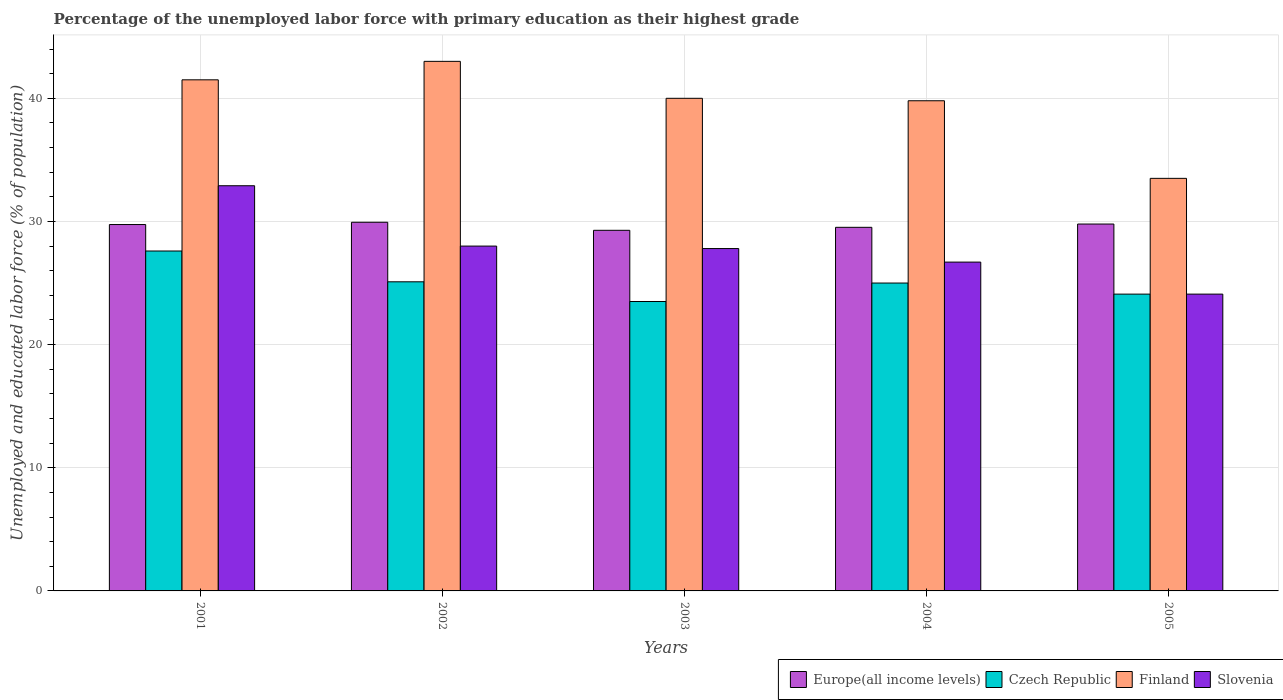How many bars are there on the 1st tick from the left?
Provide a succinct answer. 4. How many bars are there on the 5th tick from the right?
Give a very brief answer. 4. What is the label of the 4th group of bars from the left?
Give a very brief answer. 2004. In how many cases, is the number of bars for a given year not equal to the number of legend labels?
Provide a short and direct response. 0. What is the percentage of the unemployed labor force with primary education in Europe(all income levels) in 2001?
Your response must be concise. 29.75. Across all years, what is the maximum percentage of the unemployed labor force with primary education in Czech Republic?
Ensure brevity in your answer.  27.6. Across all years, what is the minimum percentage of the unemployed labor force with primary education in Europe(all income levels)?
Provide a short and direct response. 29.28. In which year was the percentage of the unemployed labor force with primary education in Czech Republic maximum?
Your answer should be compact. 2001. What is the total percentage of the unemployed labor force with primary education in Finland in the graph?
Make the answer very short. 197.8. What is the difference between the percentage of the unemployed labor force with primary education in Czech Republic in 2003 and that in 2005?
Keep it short and to the point. -0.6. What is the difference between the percentage of the unemployed labor force with primary education in Czech Republic in 2002 and the percentage of the unemployed labor force with primary education in Slovenia in 2004?
Offer a very short reply. -1.6. What is the average percentage of the unemployed labor force with primary education in Czech Republic per year?
Make the answer very short. 25.06. In the year 2002, what is the difference between the percentage of the unemployed labor force with primary education in Europe(all income levels) and percentage of the unemployed labor force with primary education in Finland?
Your answer should be very brief. -13.07. In how many years, is the percentage of the unemployed labor force with primary education in Finland greater than 36 %?
Your response must be concise. 4. What is the ratio of the percentage of the unemployed labor force with primary education in Slovenia in 2001 to that in 2002?
Provide a short and direct response. 1.18. What is the difference between the highest and the lowest percentage of the unemployed labor force with primary education in Europe(all income levels)?
Give a very brief answer. 0.65. In how many years, is the percentage of the unemployed labor force with primary education in Europe(all income levels) greater than the average percentage of the unemployed labor force with primary education in Europe(all income levels) taken over all years?
Offer a terse response. 3. Is the sum of the percentage of the unemployed labor force with primary education in Slovenia in 2001 and 2004 greater than the maximum percentage of the unemployed labor force with primary education in Europe(all income levels) across all years?
Ensure brevity in your answer.  Yes. What does the 4th bar from the right in 2002 represents?
Provide a succinct answer. Europe(all income levels). Are all the bars in the graph horizontal?
Give a very brief answer. No. How many years are there in the graph?
Give a very brief answer. 5. What is the difference between two consecutive major ticks on the Y-axis?
Give a very brief answer. 10. Are the values on the major ticks of Y-axis written in scientific E-notation?
Your answer should be very brief. No. Does the graph contain any zero values?
Your response must be concise. No. Where does the legend appear in the graph?
Your answer should be compact. Bottom right. How many legend labels are there?
Ensure brevity in your answer.  4. How are the legend labels stacked?
Make the answer very short. Horizontal. What is the title of the graph?
Offer a very short reply. Percentage of the unemployed labor force with primary education as their highest grade. What is the label or title of the Y-axis?
Your answer should be compact. Unemployed and educated labor force (% of population). What is the Unemployed and educated labor force (% of population) in Europe(all income levels) in 2001?
Offer a terse response. 29.75. What is the Unemployed and educated labor force (% of population) in Czech Republic in 2001?
Ensure brevity in your answer.  27.6. What is the Unemployed and educated labor force (% of population) in Finland in 2001?
Offer a very short reply. 41.5. What is the Unemployed and educated labor force (% of population) of Slovenia in 2001?
Your answer should be compact. 32.9. What is the Unemployed and educated labor force (% of population) of Europe(all income levels) in 2002?
Offer a very short reply. 29.93. What is the Unemployed and educated labor force (% of population) in Czech Republic in 2002?
Give a very brief answer. 25.1. What is the Unemployed and educated labor force (% of population) of Finland in 2002?
Provide a succinct answer. 43. What is the Unemployed and educated labor force (% of population) in Europe(all income levels) in 2003?
Your answer should be compact. 29.28. What is the Unemployed and educated labor force (% of population) of Slovenia in 2003?
Offer a very short reply. 27.8. What is the Unemployed and educated labor force (% of population) of Europe(all income levels) in 2004?
Your response must be concise. 29.52. What is the Unemployed and educated labor force (% of population) of Czech Republic in 2004?
Your answer should be compact. 25. What is the Unemployed and educated labor force (% of population) in Finland in 2004?
Provide a short and direct response. 39.8. What is the Unemployed and educated labor force (% of population) in Slovenia in 2004?
Keep it short and to the point. 26.7. What is the Unemployed and educated labor force (% of population) in Europe(all income levels) in 2005?
Provide a succinct answer. 29.79. What is the Unemployed and educated labor force (% of population) of Czech Republic in 2005?
Provide a short and direct response. 24.1. What is the Unemployed and educated labor force (% of population) in Finland in 2005?
Your response must be concise. 33.5. What is the Unemployed and educated labor force (% of population) of Slovenia in 2005?
Your answer should be very brief. 24.1. Across all years, what is the maximum Unemployed and educated labor force (% of population) of Europe(all income levels)?
Provide a short and direct response. 29.93. Across all years, what is the maximum Unemployed and educated labor force (% of population) of Czech Republic?
Provide a short and direct response. 27.6. Across all years, what is the maximum Unemployed and educated labor force (% of population) of Finland?
Ensure brevity in your answer.  43. Across all years, what is the maximum Unemployed and educated labor force (% of population) of Slovenia?
Give a very brief answer. 32.9. Across all years, what is the minimum Unemployed and educated labor force (% of population) of Europe(all income levels)?
Your response must be concise. 29.28. Across all years, what is the minimum Unemployed and educated labor force (% of population) of Czech Republic?
Provide a succinct answer. 23.5. Across all years, what is the minimum Unemployed and educated labor force (% of population) in Finland?
Offer a very short reply. 33.5. Across all years, what is the minimum Unemployed and educated labor force (% of population) of Slovenia?
Your response must be concise. 24.1. What is the total Unemployed and educated labor force (% of population) in Europe(all income levels) in the graph?
Your response must be concise. 148.28. What is the total Unemployed and educated labor force (% of population) of Czech Republic in the graph?
Provide a succinct answer. 125.3. What is the total Unemployed and educated labor force (% of population) in Finland in the graph?
Your response must be concise. 197.8. What is the total Unemployed and educated labor force (% of population) in Slovenia in the graph?
Provide a succinct answer. 139.5. What is the difference between the Unemployed and educated labor force (% of population) in Europe(all income levels) in 2001 and that in 2002?
Give a very brief answer. -0.18. What is the difference between the Unemployed and educated labor force (% of population) of Czech Republic in 2001 and that in 2002?
Your answer should be very brief. 2.5. What is the difference between the Unemployed and educated labor force (% of population) of Slovenia in 2001 and that in 2002?
Make the answer very short. 4.9. What is the difference between the Unemployed and educated labor force (% of population) in Europe(all income levels) in 2001 and that in 2003?
Give a very brief answer. 0.47. What is the difference between the Unemployed and educated labor force (% of population) in Finland in 2001 and that in 2003?
Ensure brevity in your answer.  1.5. What is the difference between the Unemployed and educated labor force (% of population) of Slovenia in 2001 and that in 2003?
Your response must be concise. 5.1. What is the difference between the Unemployed and educated labor force (% of population) of Europe(all income levels) in 2001 and that in 2004?
Your answer should be compact. 0.23. What is the difference between the Unemployed and educated labor force (% of population) in Czech Republic in 2001 and that in 2004?
Ensure brevity in your answer.  2.6. What is the difference between the Unemployed and educated labor force (% of population) of Finland in 2001 and that in 2004?
Offer a terse response. 1.7. What is the difference between the Unemployed and educated labor force (% of population) of Slovenia in 2001 and that in 2004?
Offer a very short reply. 6.2. What is the difference between the Unemployed and educated labor force (% of population) in Europe(all income levels) in 2001 and that in 2005?
Offer a terse response. -0.04. What is the difference between the Unemployed and educated labor force (% of population) of Europe(all income levels) in 2002 and that in 2003?
Provide a succinct answer. 0.65. What is the difference between the Unemployed and educated labor force (% of population) of Finland in 2002 and that in 2003?
Give a very brief answer. 3. What is the difference between the Unemployed and educated labor force (% of population) of Slovenia in 2002 and that in 2003?
Give a very brief answer. 0.2. What is the difference between the Unemployed and educated labor force (% of population) in Europe(all income levels) in 2002 and that in 2004?
Make the answer very short. 0.41. What is the difference between the Unemployed and educated labor force (% of population) of Europe(all income levels) in 2002 and that in 2005?
Your answer should be compact. 0.14. What is the difference between the Unemployed and educated labor force (% of population) in Slovenia in 2002 and that in 2005?
Your answer should be compact. 3.9. What is the difference between the Unemployed and educated labor force (% of population) of Europe(all income levels) in 2003 and that in 2004?
Ensure brevity in your answer.  -0.24. What is the difference between the Unemployed and educated labor force (% of population) in Finland in 2003 and that in 2004?
Offer a very short reply. 0.2. What is the difference between the Unemployed and educated labor force (% of population) in Slovenia in 2003 and that in 2004?
Keep it short and to the point. 1.1. What is the difference between the Unemployed and educated labor force (% of population) in Europe(all income levels) in 2003 and that in 2005?
Give a very brief answer. -0.51. What is the difference between the Unemployed and educated labor force (% of population) of Czech Republic in 2003 and that in 2005?
Ensure brevity in your answer.  -0.6. What is the difference between the Unemployed and educated labor force (% of population) of Finland in 2003 and that in 2005?
Make the answer very short. 6.5. What is the difference between the Unemployed and educated labor force (% of population) in Europe(all income levels) in 2004 and that in 2005?
Your answer should be very brief. -0.27. What is the difference between the Unemployed and educated labor force (% of population) of Finland in 2004 and that in 2005?
Give a very brief answer. 6.3. What is the difference between the Unemployed and educated labor force (% of population) of Europe(all income levels) in 2001 and the Unemployed and educated labor force (% of population) of Czech Republic in 2002?
Keep it short and to the point. 4.65. What is the difference between the Unemployed and educated labor force (% of population) of Europe(all income levels) in 2001 and the Unemployed and educated labor force (% of population) of Finland in 2002?
Provide a succinct answer. -13.25. What is the difference between the Unemployed and educated labor force (% of population) of Europe(all income levels) in 2001 and the Unemployed and educated labor force (% of population) of Slovenia in 2002?
Make the answer very short. 1.75. What is the difference between the Unemployed and educated labor force (% of population) of Czech Republic in 2001 and the Unemployed and educated labor force (% of population) of Finland in 2002?
Keep it short and to the point. -15.4. What is the difference between the Unemployed and educated labor force (% of population) in Czech Republic in 2001 and the Unemployed and educated labor force (% of population) in Slovenia in 2002?
Your response must be concise. -0.4. What is the difference between the Unemployed and educated labor force (% of population) of Europe(all income levels) in 2001 and the Unemployed and educated labor force (% of population) of Czech Republic in 2003?
Ensure brevity in your answer.  6.25. What is the difference between the Unemployed and educated labor force (% of population) in Europe(all income levels) in 2001 and the Unemployed and educated labor force (% of population) in Finland in 2003?
Provide a succinct answer. -10.25. What is the difference between the Unemployed and educated labor force (% of population) in Europe(all income levels) in 2001 and the Unemployed and educated labor force (% of population) in Slovenia in 2003?
Ensure brevity in your answer.  1.95. What is the difference between the Unemployed and educated labor force (% of population) in Czech Republic in 2001 and the Unemployed and educated labor force (% of population) in Finland in 2003?
Offer a terse response. -12.4. What is the difference between the Unemployed and educated labor force (% of population) in Finland in 2001 and the Unemployed and educated labor force (% of population) in Slovenia in 2003?
Keep it short and to the point. 13.7. What is the difference between the Unemployed and educated labor force (% of population) in Europe(all income levels) in 2001 and the Unemployed and educated labor force (% of population) in Czech Republic in 2004?
Your answer should be compact. 4.75. What is the difference between the Unemployed and educated labor force (% of population) in Europe(all income levels) in 2001 and the Unemployed and educated labor force (% of population) in Finland in 2004?
Make the answer very short. -10.05. What is the difference between the Unemployed and educated labor force (% of population) of Europe(all income levels) in 2001 and the Unemployed and educated labor force (% of population) of Slovenia in 2004?
Offer a terse response. 3.05. What is the difference between the Unemployed and educated labor force (% of population) in Czech Republic in 2001 and the Unemployed and educated labor force (% of population) in Finland in 2004?
Your answer should be compact. -12.2. What is the difference between the Unemployed and educated labor force (% of population) of Czech Republic in 2001 and the Unemployed and educated labor force (% of population) of Slovenia in 2004?
Offer a terse response. 0.9. What is the difference between the Unemployed and educated labor force (% of population) in Finland in 2001 and the Unemployed and educated labor force (% of population) in Slovenia in 2004?
Your response must be concise. 14.8. What is the difference between the Unemployed and educated labor force (% of population) of Europe(all income levels) in 2001 and the Unemployed and educated labor force (% of population) of Czech Republic in 2005?
Your answer should be compact. 5.65. What is the difference between the Unemployed and educated labor force (% of population) in Europe(all income levels) in 2001 and the Unemployed and educated labor force (% of population) in Finland in 2005?
Provide a short and direct response. -3.75. What is the difference between the Unemployed and educated labor force (% of population) in Europe(all income levels) in 2001 and the Unemployed and educated labor force (% of population) in Slovenia in 2005?
Your answer should be compact. 5.65. What is the difference between the Unemployed and educated labor force (% of population) of Czech Republic in 2001 and the Unemployed and educated labor force (% of population) of Finland in 2005?
Ensure brevity in your answer.  -5.9. What is the difference between the Unemployed and educated labor force (% of population) of Czech Republic in 2001 and the Unemployed and educated labor force (% of population) of Slovenia in 2005?
Offer a very short reply. 3.5. What is the difference between the Unemployed and educated labor force (% of population) of Finland in 2001 and the Unemployed and educated labor force (% of population) of Slovenia in 2005?
Your answer should be compact. 17.4. What is the difference between the Unemployed and educated labor force (% of population) of Europe(all income levels) in 2002 and the Unemployed and educated labor force (% of population) of Czech Republic in 2003?
Your answer should be compact. 6.43. What is the difference between the Unemployed and educated labor force (% of population) of Europe(all income levels) in 2002 and the Unemployed and educated labor force (% of population) of Finland in 2003?
Your response must be concise. -10.07. What is the difference between the Unemployed and educated labor force (% of population) of Europe(all income levels) in 2002 and the Unemployed and educated labor force (% of population) of Slovenia in 2003?
Your answer should be very brief. 2.13. What is the difference between the Unemployed and educated labor force (% of population) of Czech Republic in 2002 and the Unemployed and educated labor force (% of population) of Finland in 2003?
Your answer should be compact. -14.9. What is the difference between the Unemployed and educated labor force (% of population) in Finland in 2002 and the Unemployed and educated labor force (% of population) in Slovenia in 2003?
Your answer should be compact. 15.2. What is the difference between the Unemployed and educated labor force (% of population) of Europe(all income levels) in 2002 and the Unemployed and educated labor force (% of population) of Czech Republic in 2004?
Provide a short and direct response. 4.93. What is the difference between the Unemployed and educated labor force (% of population) in Europe(all income levels) in 2002 and the Unemployed and educated labor force (% of population) in Finland in 2004?
Make the answer very short. -9.87. What is the difference between the Unemployed and educated labor force (% of population) in Europe(all income levels) in 2002 and the Unemployed and educated labor force (% of population) in Slovenia in 2004?
Ensure brevity in your answer.  3.23. What is the difference between the Unemployed and educated labor force (% of population) of Czech Republic in 2002 and the Unemployed and educated labor force (% of population) of Finland in 2004?
Provide a short and direct response. -14.7. What is the difference between the Unemployed and educated labor force (% of population) of Czech Republic in 2002 and the Unemployed and educated labor force (% of population) of Slovenia in 2004?
Give a very brief answer. -1.6. What is the difference between the Unemployed and educated labor force (% of population) of Europe(all income levels) in 2002 and the Unemployed and educated labor force (% of population) of Czech Republic in 2005?
Your response must be concise. 5.83. What is the difference between the Unemployed and educated labor force (% of population) of Europe(all income levels) in 2002 and the Unemployed and educated labor force (% of population) of Finland in 2005?
Ensure brevity in your answer.  -3.57. What is the difference between the Unemployed and educated labor force (% of population) of Europe(all income levels) in 2002 and the Unemployed and educated labor force (% of population) of Slovenia in 2005?
Provide a short and direct response. 5.83. What is the difference between the Unemployed and educated labor force (% of population) in Czech Republic in 2002 and the Unemployed and educated labor force (% of population) in Finland in 2005?
Provide a succinct answer. -8.4. What is the difference between the Unemployed and educated labor force (% of population) of Czech Republic in 2002 and the Unemployed and educated labor force (% of population) of Slovenia in 2005?
Provide a succinct answer. 1. What is the difference between the Unemployed and educated labor force (% of population) of Finland in 2002 and the Unemployed and educated labor force (% of population) of Slovenia in 2005?
Your answer should be compact. 18.9. What is the difference between the Unemployed and educated labor force (% of population) of Europe(all income levels) in 2003 and the Unemployed and educated labor force (% of population) of Czech Republic in 2004?
Provide a succinct answer. 4.28. What is the difference between the Unemployed and educated labor force (% of population) of Europe(all income levels) in 2003 and the Unemployed and educated labor force (% of population) of Finland in 2004?
Provide a short and direct response. -10.52. What is the difference between the Unemployed and educated labor force (% of population) in Europe(all income levels) in 2003 and the Unemployed and educated labor force (% of population) in Slovenia in 2004?
Your response must be concise. 2.58. What is the difference between the Unemployed and educated labor force (% of population) of Czech Republic in 2003 and the Unemployed and educated labor force (% of population) of Finland in 2004?
Keep it short and to the point. -16.3. What is the difference between the Unemployed and educated labor force (% of population) in Czech Republic in 2003 and the Unemployed and educated labor force (% of population) in Slovenia in 2004?
Provide a succinct answer. -3.2. What is the difference between the Unemployed and educated labor force (% of population) in Finland in 2003 and the Unemployed and educated labor force (% of population) in Slovenia in 2004?
Make the answer very short. 13.3. What is the difference between the Unemployed and educated labor force (% of population) in Europe(all income levels) in 2003 and the Unemployed and educated labor force (% of population) in Czech Republic in 2005?
Keep it short and to the point. 5.18. What is the difference between the Unemployed and educated labor force (% of population) in Europe(all income levels) in 2003 and the Unemployed and educated labor force (% of population) in Finland in 2005?
Ensure brevity in your answer.  -4.22. What is the difference between the Unemployed and educated labor force (% of population) of Europe(all income levels) in 2003 and the Unemployed and educated labor force (% of population) of Slovenia in 2005?
Provide a succinct answer. 5.18. What is the difference between the Unemployed and educated labor force (% of population) in Czech Republic in 2003 and the Unemployed and educated labor force (% of population) in Finland in 2005?
Your answer should be compact. -10. What is the difference between the Unemployed and educated labor force (% of population) of Czech Republic in 2003 and the Unemployed and educated labor force (% of population) of Slovenia in 2005?
Your answer should be compact. -0.6. What is the difference between the Unemployed and educated labor force (% of population) of Finland in 2003 and the Unemployed and educated labor force (% of population) of Slovenia in 2005?
Your answer should be compact. 15.9. What is the difference between the Unemployed and educated labor force (% of population) in Europe(all income levels) in 2004 and the Unemployed and educated labor force (% of population) in Czech Republic in 2005?
Provide a succinct answer. 5.42. What is the difference between the Unemployed and educated labor force (% of population) in Europe(all income levels) in 2004 and the Unemployed and educated labor force (% of population) in Finland in 2005?
Give a very brief answer. -3.98. What is the difference between the Unemployed and educated labor force (% of population) of Europe(all income levels) in 2004 and the Unemployed and educated labor force (% of population) of Slovenia in 2005?
Your answer should be very brief. 5.42. What is the difference between the Unemployed and educated labor force (% of population) in Czech Republic in 2004 and the Unemployed and educated labor force (% of population) in Finland in 2005?
Provide a succinct answer. -8.5. What is the average Unemployed and educated labor force (% of population) in Europe(all income levels) per year?
Ensure brevity in your answer.  29.66. What is the average Unemployed and educated labor force (% of population) of Czech Republic per year?
Your answer should be very brief. 25.06. What is the average Unemployed and educated labor force (% of population) in Finland per year?
Ensure brevity in your answer.  39.56. What is the average Unemployed and educated labor force (% of population) in Slovenia per year?
Provide a succinct answer. 27.9. In the year 2001, what is the difference between the Unemployed and educated labor force (% of population) of Europe(all income levels) and Unemployed and educated labor force (% of population) of Czech Republic?
Your answer should be very brief. 2.15. In the year 2001, what is the difference between the Unemployed and educated labor force (% of population) in Europe(all income levels) and Unemployed and educated labor force (% of population) in Finland?
Offer a terse response. -11.75. In the year 2001, what is the difference between the Unemployed and educated labor force (% of population) in Europe(all income levels) and Unemployed and educated labor force (% of population) in Slovenia?
Provide a succinct answer. -3.15. In the year 2001, what is the difference between the Unemployed and educated labor force (% of population) in Czech Republic and Unemployed and educated labor force (% of population) in Slovenia?
Give a very brief answer. -5.3. In the year 2001, what is the difference between the Unemployed and educated labor force (% of population) of Finland and Unemployed and educated labor force (% of population) of Slovenia?
Your answer should be very brief. 8.6. In the year 2002, what is the difference between the Unemployed and educated labor force (% of population) in Europe(all income levels) and Unemployed and educated labor force (% of population) in Czech Republic?
Offer a terse response. 4.83. In the year 2002, what is the difference between the Unemployed and educated labor force (% of population) of Europe(all income levels) and Unemployed and educated labor force (% of population) of Finland?
Keep it short and to the point. -13.07. In the year 2002, what is the difference between the Unemployed and educated labor force (% of population) of Europe(all income levels) and Unemployed and educated labor force (% of population) of Slovenia?
Your answer should be very brief. 1.93. In the year 2002, what is the difference between the Unemployed and educated labor force (% of population) of Czech Republic and Unemployed and educated labor force (% of population) of Finland?
Offer a terse response. -17.9. In the year 2003, what is the difference between the Unemployed and educated labor force (% of population) in Europe(all income levels) and Unemployed and educated labor force (% of population) in Czech Republic?
Your answer should be very brief. 5.78. In the year 2003, what is the difference between the Unemployed and educated labor force (% of population) of Europe(all income levels) and Unemployed and educated labor force (% of population) of Finland?
Keep it short and to the point. -10.72. In the year 2003, what is the difference between the Unemployed and educated labor force (% of population) in Europe(all income levels) and Unemployed and educated labor force (% of population) in Slovenia?
Your answer should be very brief. 1.48. In the year 2003, what is the difference between the Unemployed and educated labor force (% of population) of Czech Republic and Unemployed and educated labor force (% of population) of Finland?
Ensure brevity in your answer.  -16.5. In the year 2003, what is the difference between the Unemployed and educated labor force (% of population) of Czech Republic and Unemployed and educated labor force (% of population) of Slovenia?
Give a very brief answer. -4.3. In the year 2004, what is the difference between the Unemployed and educated labor force (% of population) of Europe(all income levels) and Unemployed and educated labor force (% of population) of Czech Republic?
Ensure brevity in your answer.  4.52. In the year 2004, what is the difference between the Unemployed and educated labor force (% of population) in Europe(all income levels) and Unemployed and educated labor force (% of population) in Finland?
Keep it short and to the point. -10.28. In the year 2004, what is the difference between the Unemployed and educated labor force (% of population) in Europe(all income levels) and Unemployed and educated labor force (% of population) in Slovenia?
Your answer should be very brief. 2.82. In the year 2004, what is the difference between the Unemployed and educated labor force (% of population) of Czech Republic and Unemployed and educated labor force (% of population) of Finland?
Provide a succinct answer. -14.8. In the year 2005, what is the difference between the Unemployed and educated labor force (% of population) of Europe(all income levels) and Unemployed and educated labor force (% of population) of Czech Republic?
Offer a terse response. 5.69. In the year 2005, what is the difference between the Unemployed and educated labor force (% of population) of Europe(all income levels) and Unemployed and educated labor force (% of population) of Finland?
Make the answer very short. -3.71. In the year 2005, what is the difference between the Unemployed and educated labor force (% of population) in Europe(all income levels) and Unemployed and educated labor force (% of population) in Slovenia?
Your answer should be very brief. 5.69. In the year 2005, what is the difference between the Unemployed and educated labor force (% of population) of Czech Republic and Unemployed and educated labor force (% of population) of Slovenia?
Make the answer very short. 0. In the year 2005, what is the difference between the Unemployed and educated labor force (% of population) of Finland and Unemployed and educated labor force (% of population) of Slovenia?
Provide a short and direct response. 9.4. What is the ratio of the Unemployed and educated labor force (% of population) in Europe(all income levels) in 2001 to that in 2002?
Ensure brevity in your answer.  0.99. What is the ratio of the Unemployed and educated labor force (% of population) of Czech Republic in 2001 to that in 2002?
Ensure brevity in your answer.  1.1. What is the ratio of the Unemployed and educated labor force (% of population) of Finland in 2001 to that in 2002?
Ensure brevity in your answer.  0.97. What is the ratio of the Unemployed and educated labor force (% of population) in Slovenia in 2001 to that in 2002?
Your answer should be compact. 1.18. What is the ratio of the Unemployed and educated labor force (% of population) in Czech Republic in 2001 to that in 2003?
Ensure brevity in your answer.  1.17. What is the ratio of the Unemployed and educated labor force (% of population) of Finland in 2001 to that in 2003?
Your answer should be compact. 1.04. What is the ratio of the Unemployed and educated labor force (% of population) of Slovenia in 2001 to that in 2003?
Give a very brief answer. 1.18. What is the ratio of the Unemployed and educated labor force (% of population) of Europe(all income levels) in 2001 to that in 2004?
Provide a succinct answer. 1.01. What is the ratio of the Unemployed and educated labor force (% of population) in Czech Republic in 2001 to that in 2004?
Provide a short and direct response. 1.1. What is the ratio of the Unemployed and educated labor force (% of population) in Finland in 2001 to that in 2004?
Make the answer very short. 1.04. What is the ratio of the Unemployed and educated labor force (% of population) in Slovenia in 2001 to that in 2004?
Your answer should be very brief. 1.23. What is the ratio of the Unemployed and educated labor force (% of population) in Europe(all income levels) in 2001 to that in 2005?
Provide a succinct answer. 1. What is the ratio of the Unemployed and educated labor force (% of population) of Czech Republic in 2001 to that in 2005?
Offer a very short reply. 1.15. What is the ratio of the Unemployed and educated labor force (% of population) of Finland in 2001 to that in 2005?
Provide a succinct answer. 1.24. What is the ratio of the Unemployed and educated labor force (% of population) of Slovenia in 2001 to that in 2005?
Offer a very short reply. 1.37. What is the ratio of the Unemployed and educated labor force (% of population) of Europe(all income levels) in 2002 to that in 2003?
Keep it short and to the point. 1.02. What is the ratio of the Unemployed and educated labor force (% of population) of Czech Republic in 2002 to that in 2003?
Give a very brief answer. 1.07. What is the ratio of the Unemployed and educated labor force (% of population) of Finland in 2002 to that in 2003?
Your response must be concise. 1.07. What is the ratio of the Unemployed and educated labor force (% of population) in Europe(all income levels) in 2002 to that in 2004?
Give a very brief answer. 1.01. What is the ratio of the Unemployed and educated labor force (% of population) in Finland in 2002 to that in 2004?
Ensure brevity in your answer.  1.08. What is the ratio of the Unemployed and educated labor force (% of population) of Slovenia in 2002 to that in 2004?
Keep it short and to the point. 1.05. What is the ratio of the Unemployed and educated labor force (% of population) of Europe(all income levels) in 2002 to that in 2005?
Provide a succinct answer. 1. What is the ratio of the Unemployed and educated labor force (% of population) of Czech Republic in 2002 to that in 2005?
Provide a succinct answer. 1.04. What is the ratio of the Unemployed and educated labor force (% of population) of Finland in 2002 to that in 2005?
Provide a short and direct response. 1.28. What is the ratio of the Unemployed and educated labor force (% of population) of Slovenia in 2002 to that in 2005?
Provide a succinct answer. 1.16. What is the ratio of the Unemployed and educated labor force (% of population) in Slovenia in 2003 to that in 2004?
Give a very brief answer. 1.04. What is the ratio of the Unemployed and educated labor force (% of population) of Europe(all income levels) in 2003 to that in 2005?
Ensure brevity in your answer.  0.98. What is the ratio of the Unemployed and educated labor force (% of population) of Czech Republic in 2003 to that in 2005?
Keep it short and to the point. 0.98. What is the ratio of the Unemployed and educated labor force (% of population) of Finland in 2003 to that in 2005?
Offer a very short reply. 1.19. What is the ratio of the Unemployed and educated labor force (% of population) in Slovenia in 2003 to that in 2005?
Offer a terse response. 1.15. What is the ratio of the Unemployed and educated labor force (% of population) of Czech Republic in 2004 to that in 2005?
Provide a short and direct response. 1.04. What is the ratio of the Unemployed and educated labor force (% of population) in Finland in 2004 to that in 2005?
Give a very brief answer. 1.19. What is the ratio of the Unemployed and educated labor force (% of population) in Slovenia in 2004 to that in 2005?
Keep it short and to the point. 1.11. What is the difference between the highest and the second highest Unemployed and educated labor force (% of population) in Europe(all income levels)?
Give a very brief answer. 0.14. What is the difference between the highest and the lowest Unemployed and educated labor force (% of population) in Europe(all income levels)?
Give a very brief answer. 0.65. What is the difference between the highest and the lowest Unemployed and educated labor force (% of population) in Czech Republic?
Your answer should be compact. 4.1. What is the difference between the highest and the lowest Unemployed and educated labor force (% of population) of Finland?
Your response must be concise. 9.5. 